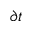<formula> <loc_0><loc_0><loc_500><loc_500>\partial t</formula> 